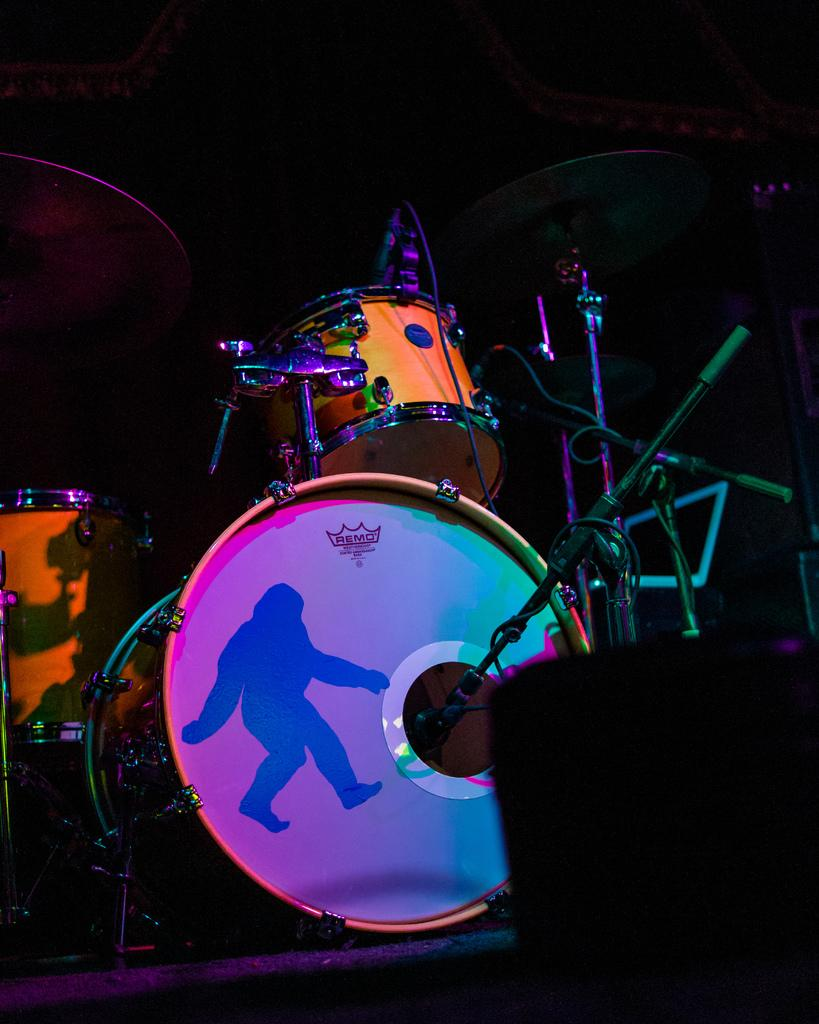What is the condition of the foreground in the image? The foreground of the image is blurred. What is the main subject in the center of the picture? There are drums and stands in the center of the picture. What else can be seen in the center of the picture besides drums and stands? There are cables and other objects in the center of the picture. How would you describe the lighting in the top part of the image? The top part of the image is dark. What type of committee is meeting in the image? There is no committee meeting in the image; it features drums, stands, cables, and other objects. How many trains are visible in the image? There are no trains present in the image. 